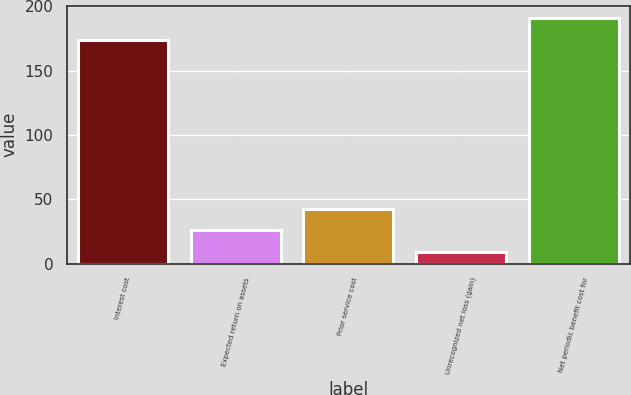Convert chart to OTSL. <chart><loc_0><loc_0><loc_500><loc_500><bar_chart><fcel>Interest cost<fcel>Expected return on assets<fcel>Prior service cost<fcel>Unrecognized net loss (gain)<fcel>Net periodic benefit cost for<nl><fcel>174<fcel>25.9<fcel>42.8<fcel>9<fcel>190.9<nl></chart> 